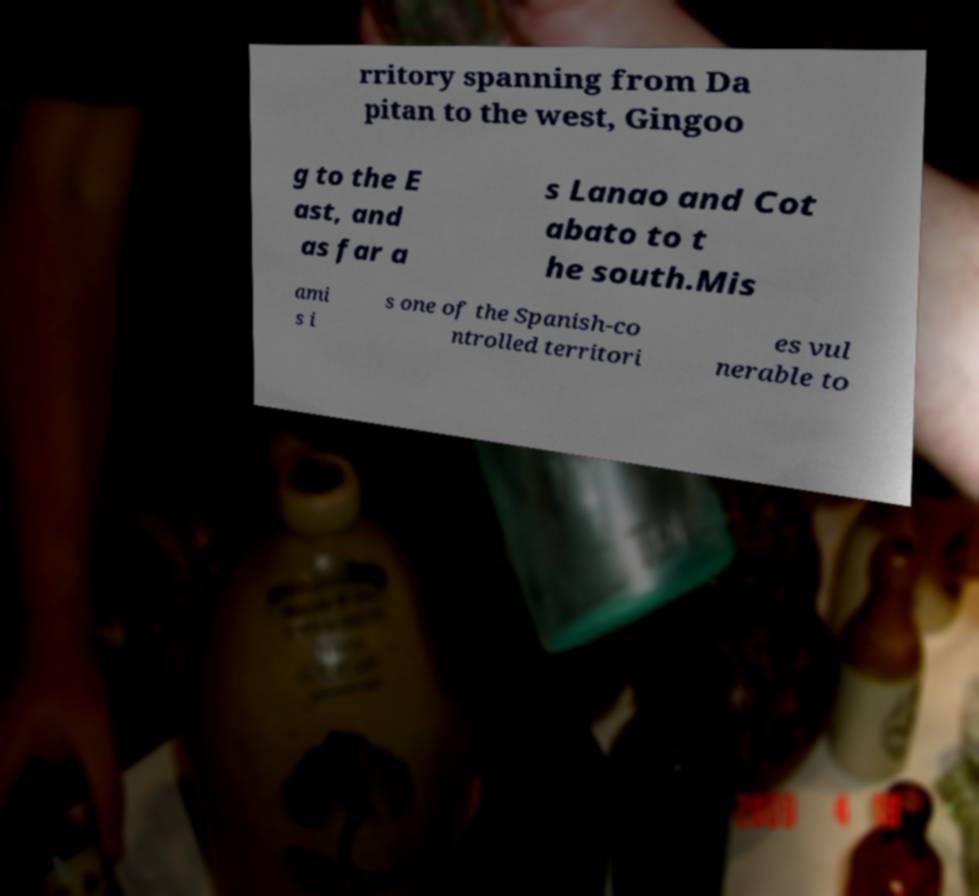For documentation purposes, I need the text within this image transcribed. Could you provide that? rritory spanning from Da pitan to the west, Gingoo g to the E ast, and as far a s Lanao and Cot abato to t he south.Mis ami s i s one of the Spanish-co ntrolled territori es vul nerable to 